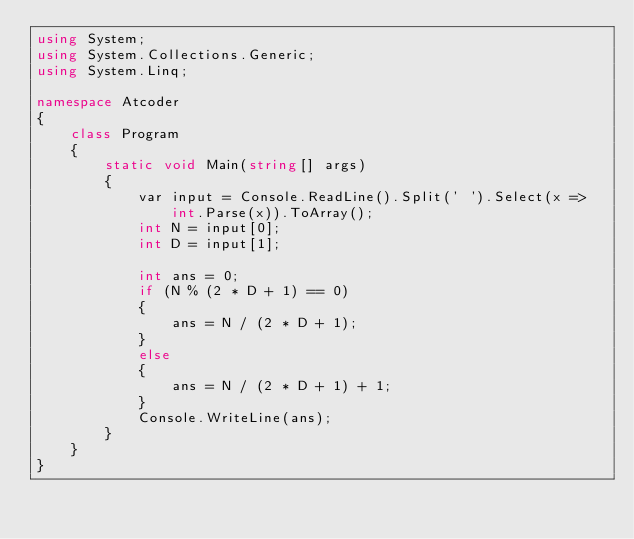Convert code to text. <code><loc_0><loc_0><loc_500><loc_500><_C#_>using System;
using System.Collections.Generic;
using System.Linq;

namespace Atcoder
{
    class Program
    {
        static void Main(string[] args)
        {
            var input = Console.ReadLine().Split(' ').Select(x => int.Parse(x)).ToArray();
            int N = input[0];
            int D = input[1];

            int ans = 0;
            if (N % (2 * D + 1) == 0)
            {
                ans = N / (2 * D + 1);
            }
            else
            {
                ans = N / (2 * D + 1) + 1;
            }
            Console.WriteLine(ans);
        }
    }
}</code> 